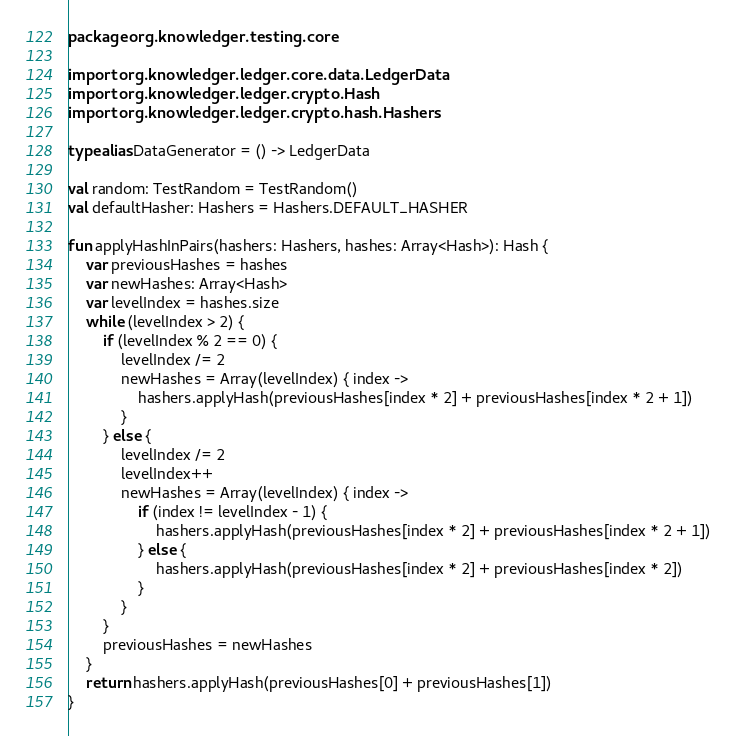Convert code to text. <code><loc_0><loc_0><loc_500><loc_500><_Kotlin_>package org.knowledger.testing.core

import org.knowledger.ledger.core.data.LedgerData
import org.knowledger.ledger.crypto.Hash
import org.knowledger.ledger.crypto.hash.Hashers

typealias DataGenerator = () -> LedgerData

val random: TestRandom = TestRandom()
val defaultHasher: Hashers = Hashers.DEFAULT_HASHER

fun applyHashInPairs(hashers: Hashers, hashes: Array<Hash>): Hash {
    var previousHashes = hashes
    var newHashes: Array<Hash>
    var levelIndex = hashes.size
    while (levelIndex > 2) {
        if (levelIndex % 2 == 0) {
            levelIndex /= 2
            newHashes = Array(levelIndex) { index ->
                hashers.applyHash(previousHashes[index * 2] + previousHashes[index * 2 + 1])
            }
        } else {
            levelIndex /= 2
            levelIndex++
            newHashes = Array(levelIndex) { index ->
                if (index != levelIndex - 1) {
                    hashers.applyHash(previousHashes[index * 2] + previousHashes[index * 2 + 1])
                } else {
                    hashers.applyHash(previousHashes[index * 2] + previousHashes[index * 2])
                }
            }
        }
        previousHashes = newHashes
    }
    return hashers.applyHash(previousHashes[0] + previousHashes[1])
}</code> 